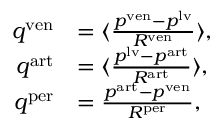<formula> <loc_0><loc_0><loc_500><loc_500>\begin{array} { r l } { q ^ { v e n } } & { = \langle \frac { p ^ { v e n } - p ^ { l v } } { R ^ { v e n } } \rangle , } \\ { q ^ { a r t } } & { = \langle \frac { p ^ { l v } - p ^ { a r t } } { R ^ { a r t } } \rangle , } \\ { q ^ { p e r } } & { = \frac { p ^ { a r t } - p ^ { v e n } } { R ^ { p e r } } , } \end{array}</formula> 